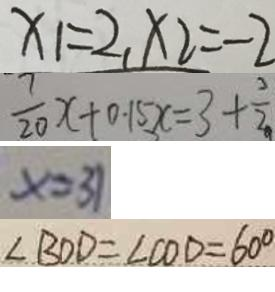<formula> <loc_0><loc_0><loc_500><loc_500>x _ { 1 } = 2 , x _ { 2 } = - 2 
 \frac { 7 } { 2 0 } x + 0 . 1 5 x = 3 + \frac { 3 } { 2 } 
 x = 3 1 
 \angle B O D = \angle C O D = 6 0 ^ { \circ }</formula> 